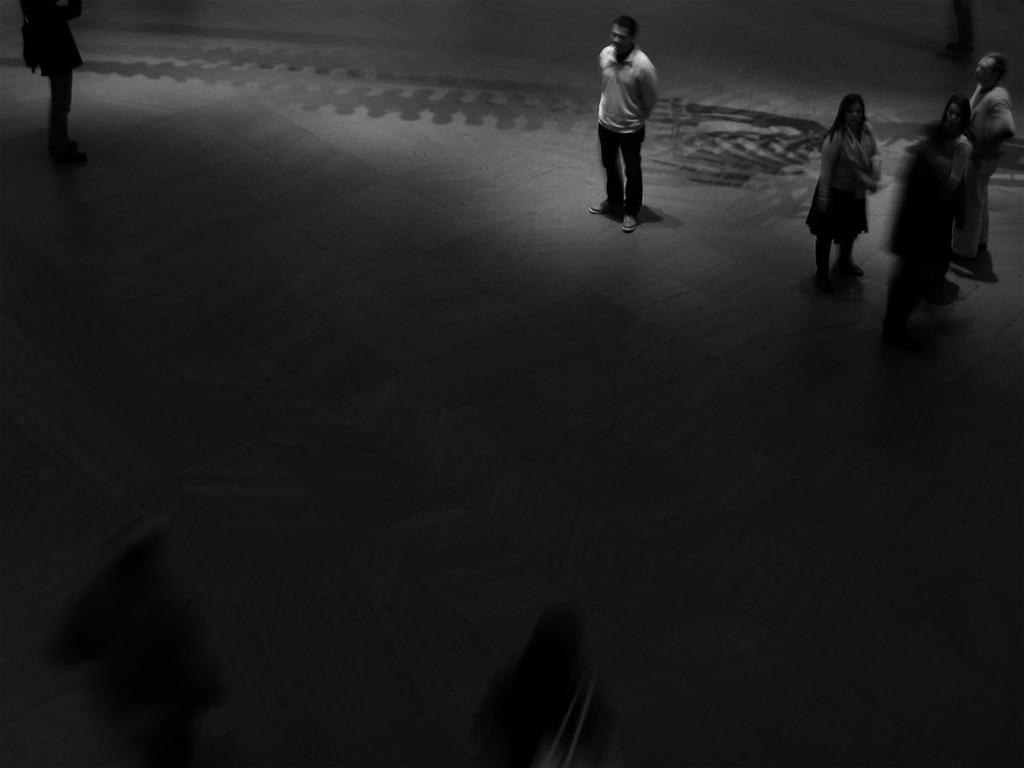What type of picture is in the image? The image contains a black and white picture. What can be seen in the picture? The picture depicts people wearing clothes. How would you describe the overall appearance of the image? The image has a pale dark appearance. What type of event is taking place in the image? There is no specific event taking place in the image; it is a picture of people wearing clothes. Can you tell me where the vase is located in the image? There is no vase present in the image. 